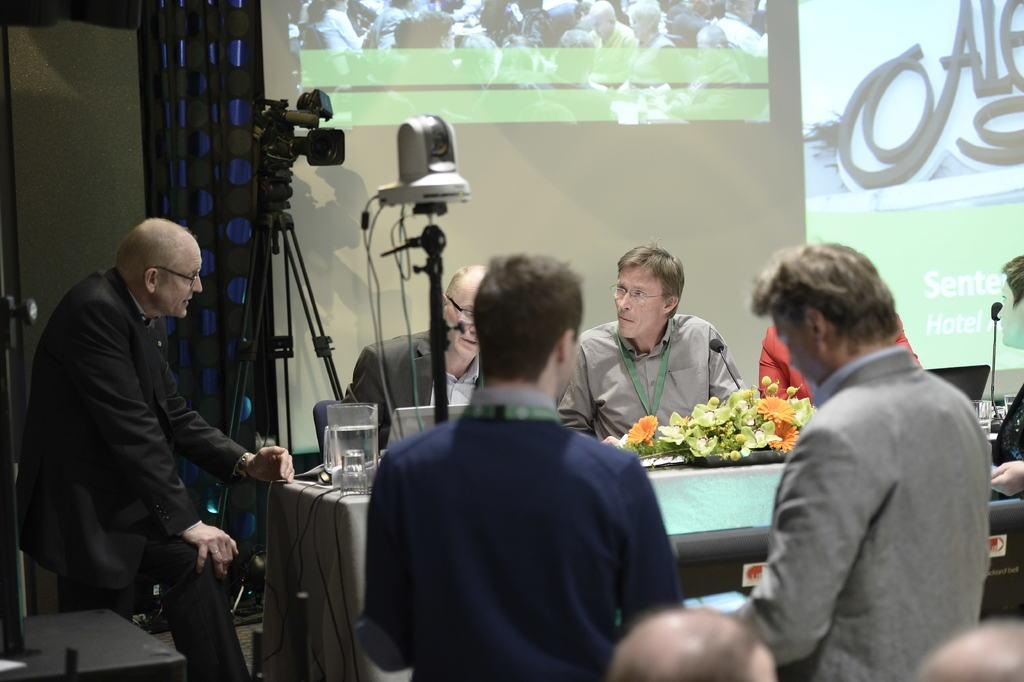How many people are present in the image? There are many people in the image. What object is in front of the people? There is a flower book in front of the people. What device is visible in the image? There is a microphone in the image. What is being projected in the image? There is a projected screen in the image. What color is the industry in the image? There is no industry present in the image, so it is not possible to determine its color. 